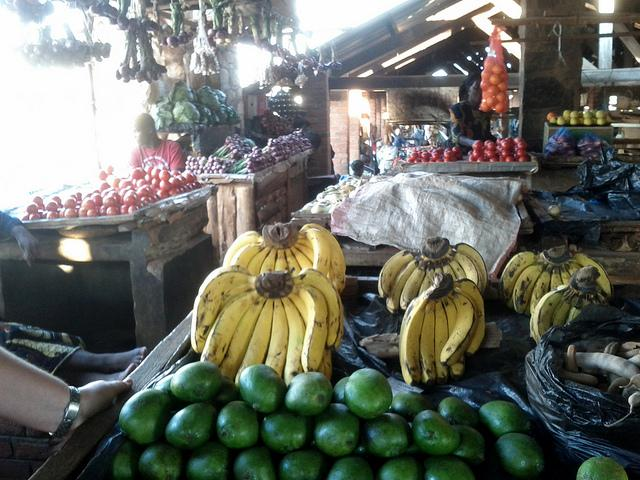What color is the fruit located under the bananas?

Choices:
A) pink
B) red
C) purple
D) green green 